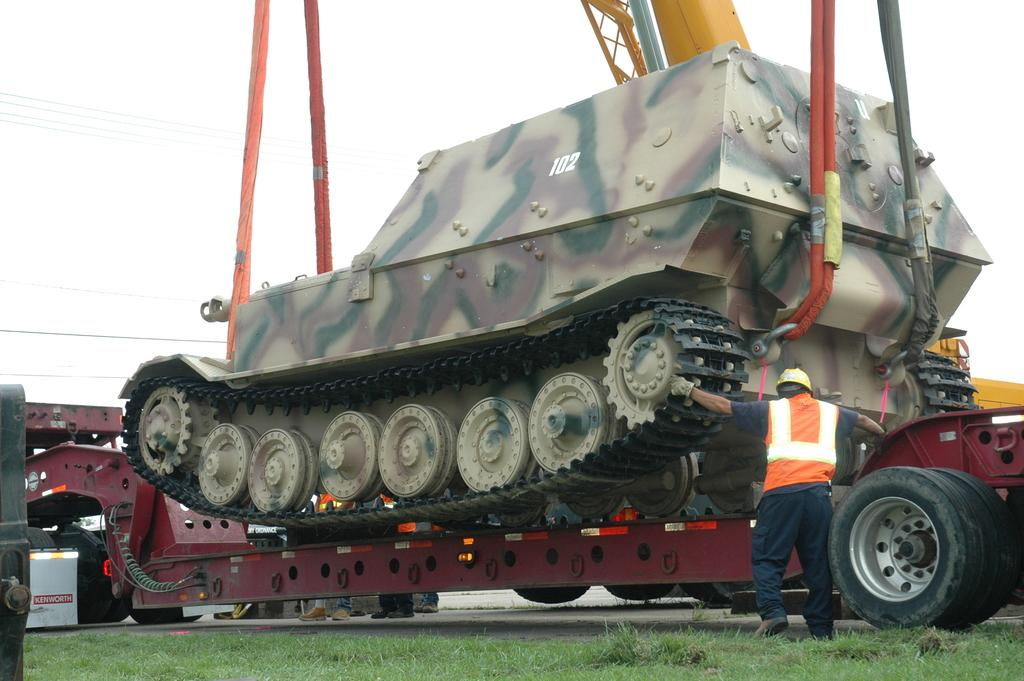What is the main subject of the image? There is a vehicle in the image. What are the people in the image doing? The people are standing on the road in the image. What type of vegetation is present in the image? Grass is present in the image. What can be seen in the background of the image? The sky is visible in the background of the image. What time of day is it in the image, and what color is the doctor's coat? The provided facts do not mention the time of day or the presence of a doctor, so we cannot determine the time or the color of the doctor's coat. 